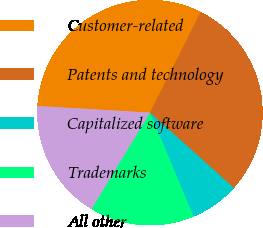Convert chart. <chart><loc_0><loc_0><loc_500><loc_500><pie_chart><fcel>Customer-related<fcel>Patents and technology<fcel>Capitalized software<fcel>Trademarks<fcel>All other<nl><fcel>31.5%<fcel>29.21%<fcel>7.04%<fcel>14.98%<fcel>17.27%<nl></chart> 